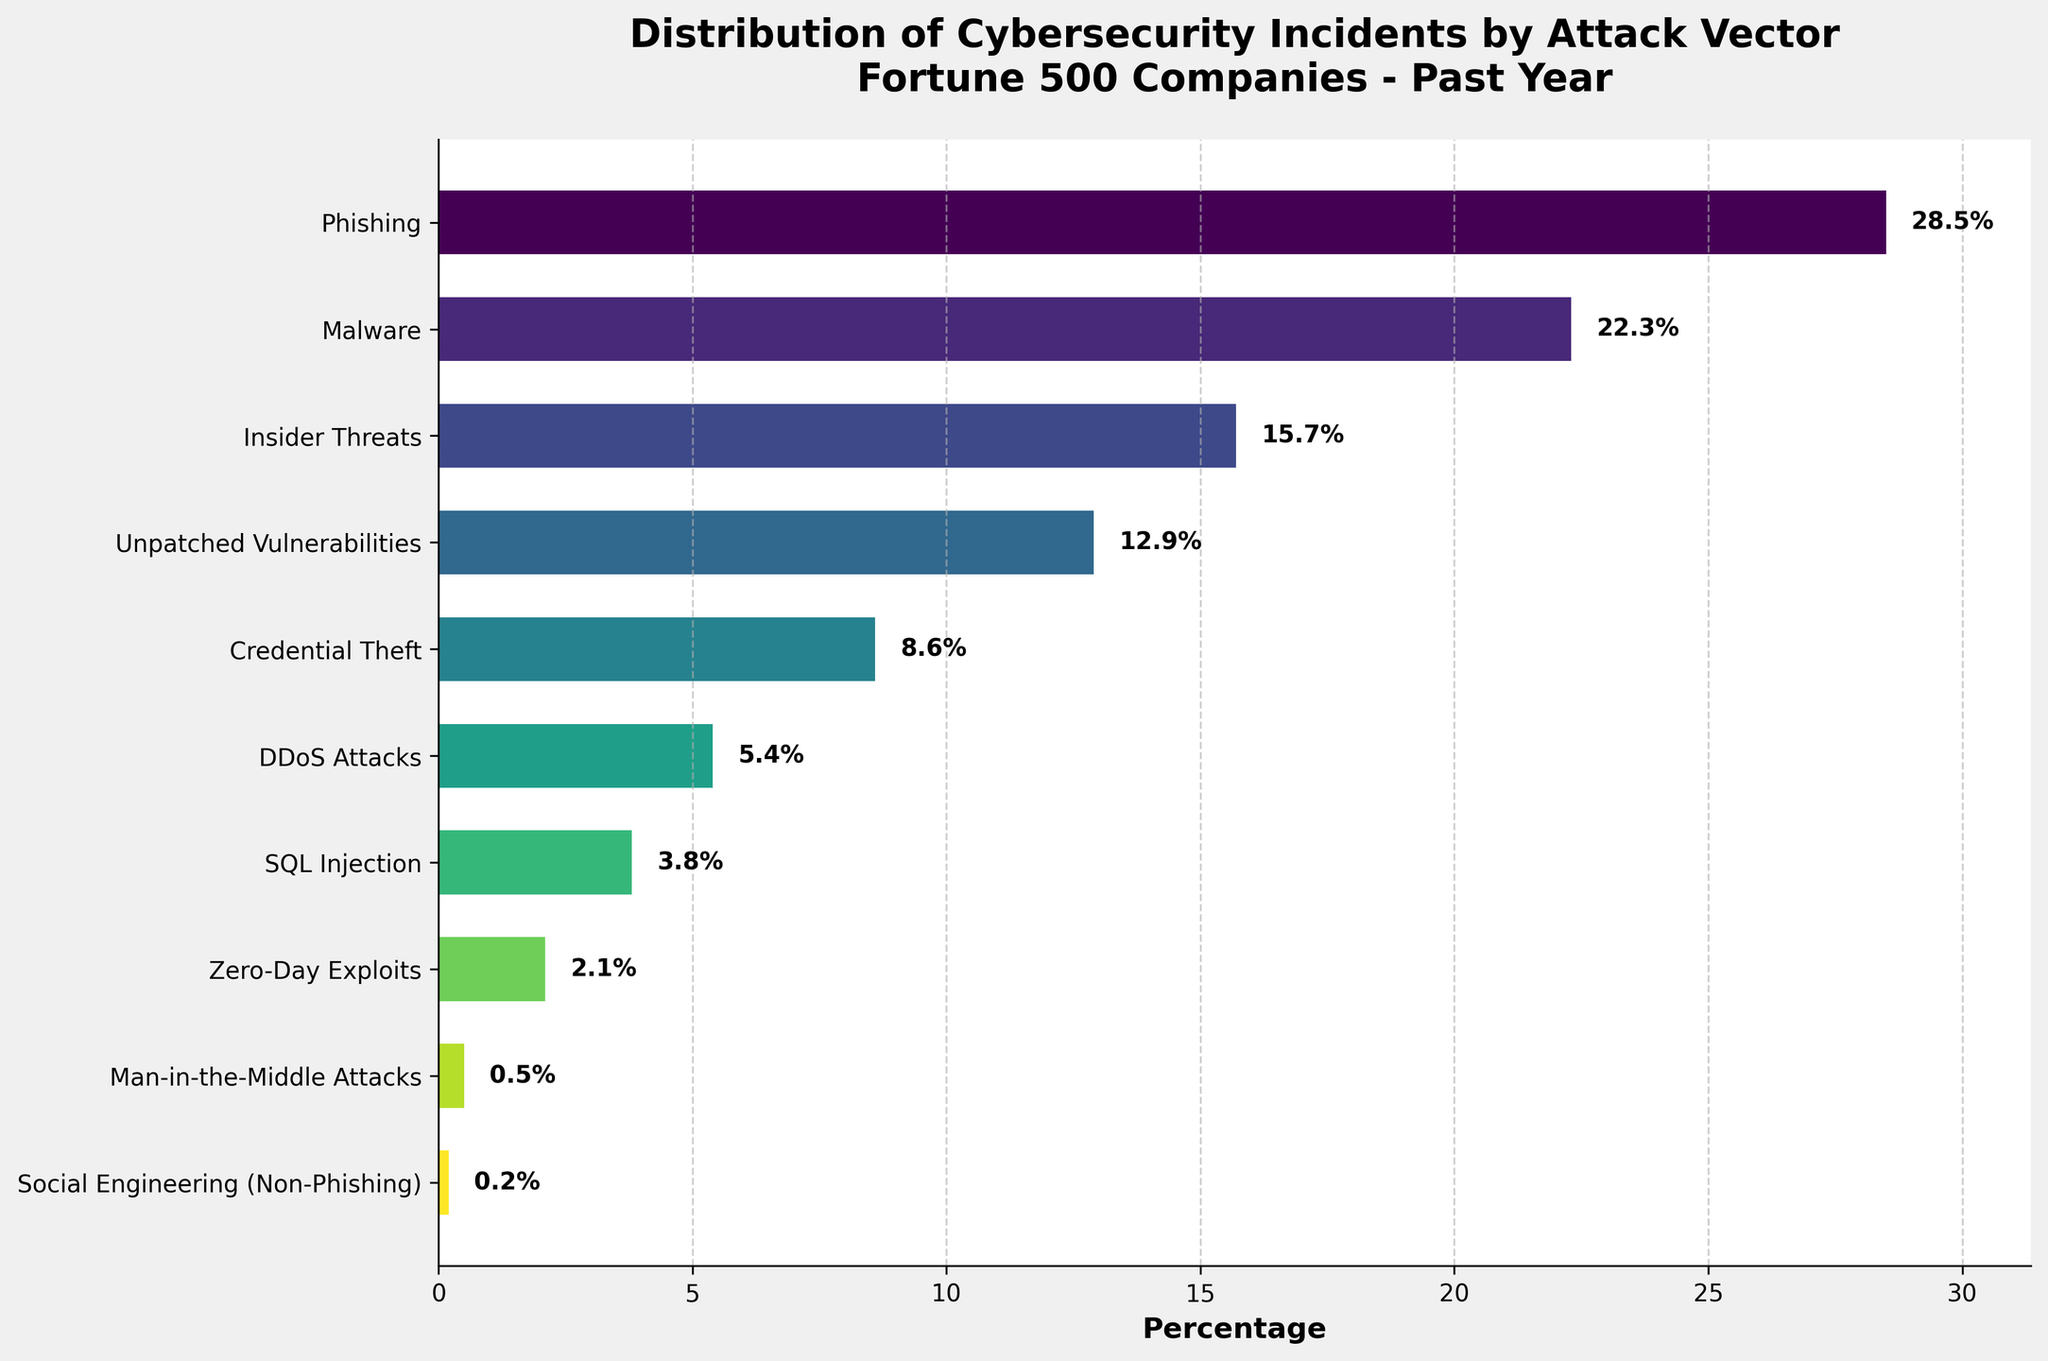Which attack vector has the highest percentage of cybersecurity incidents? The bar chart shows that the leftmost bar representing Phishing is the longest. It has a label indicating a percentage of 28.5%.
Answer: Phishing What is the difference in percentage between Malware and Credential Theft incidents? The percentage for Malware is 22.3% and for Credential Theft is 8.6%. The difference is calculated as 22.3% - 8.6% = 13.7%.
Answer: 13.7% Are DDoS Attacks more or less common than Insider Threats? By comparing the bars on the chart, DDoS Attacks have a percentage of 5.4%, while Insider Threats have a percentage of 15.7%. Therefore, DDoS Attacks are less common than Insider Threats.
Answer: Less common What is the combined percentage of Phishing, Malware, and Insider Threats incidents? The percentages are Phishing (28.5%), Malware (22.3%), and Insider Threats (15.7%). Adding these, 28.5% + 22.3% + 15.7% = 66.5%.
Answer: 66.5% Which attack vector has the smallest percentage of cybersecurity incidents? The smallest bar on the chart corresponds to Social Engineering (Non-Phishing) with a percentage of 0.2%.
Answer: Social Engineering (Non-Phishing) How many attack vectors have a percentage greater than 10%? By examining the chart, the attack vectors with percentages greater than 10% are Phishing (28.5%), Malware (22.3%), and Insider Threats (15.7%), and Unpatched Vulnerabilities (12.9%). Thus, there are 4 vectors over 10%.
Answer: 4 Is the percentage of Unpatched Vulnerabilities nearer to that of Insider Threats or Credential Theft? The percentage of Unpatched Vulnerabilities is 12.9%. Comparing it to Insider Threats (15.7%) and Credential Theft (8.6%), the difference with Insider Threats is 15.7% - 12.9% = 2.8% and with Credential Theft it is 12.9% - 8.6% = 4.3%. Therefore, it is nearer to Insider Threats.
Answer: Insider Threats What is the average percentage of DDoS Attacks, SQL Injection, and Zero-Day Exploits? The percentages are DDoS Attacks (5.4%), SQL Injection (3.8%), and Zero-Day Exploits (2.1%). The sum is 5.4% + 3.8% + 2.1% = 11.3%. The average is 11.3% / 3 = 3.77%.
Answer: 3.77% Which two attack vectors combined have the same percentage as Malware? Phishing has 28.5%, which is too high alone. Trying others: Insider Threats (15.7%) + Unpatched Vulnerabilities (12.9%) = 28.6%, which is not correct. Credential Theft (8.6%) + DDoS Attacks (5.4%) = 14%, SQL Injection (3.8%) + Zero-Day Exploits (2.1%) = 5.9%, etc. The correct combination doesn't match exactly 22.3%. Therefore, the answer is none.
Answer: None 